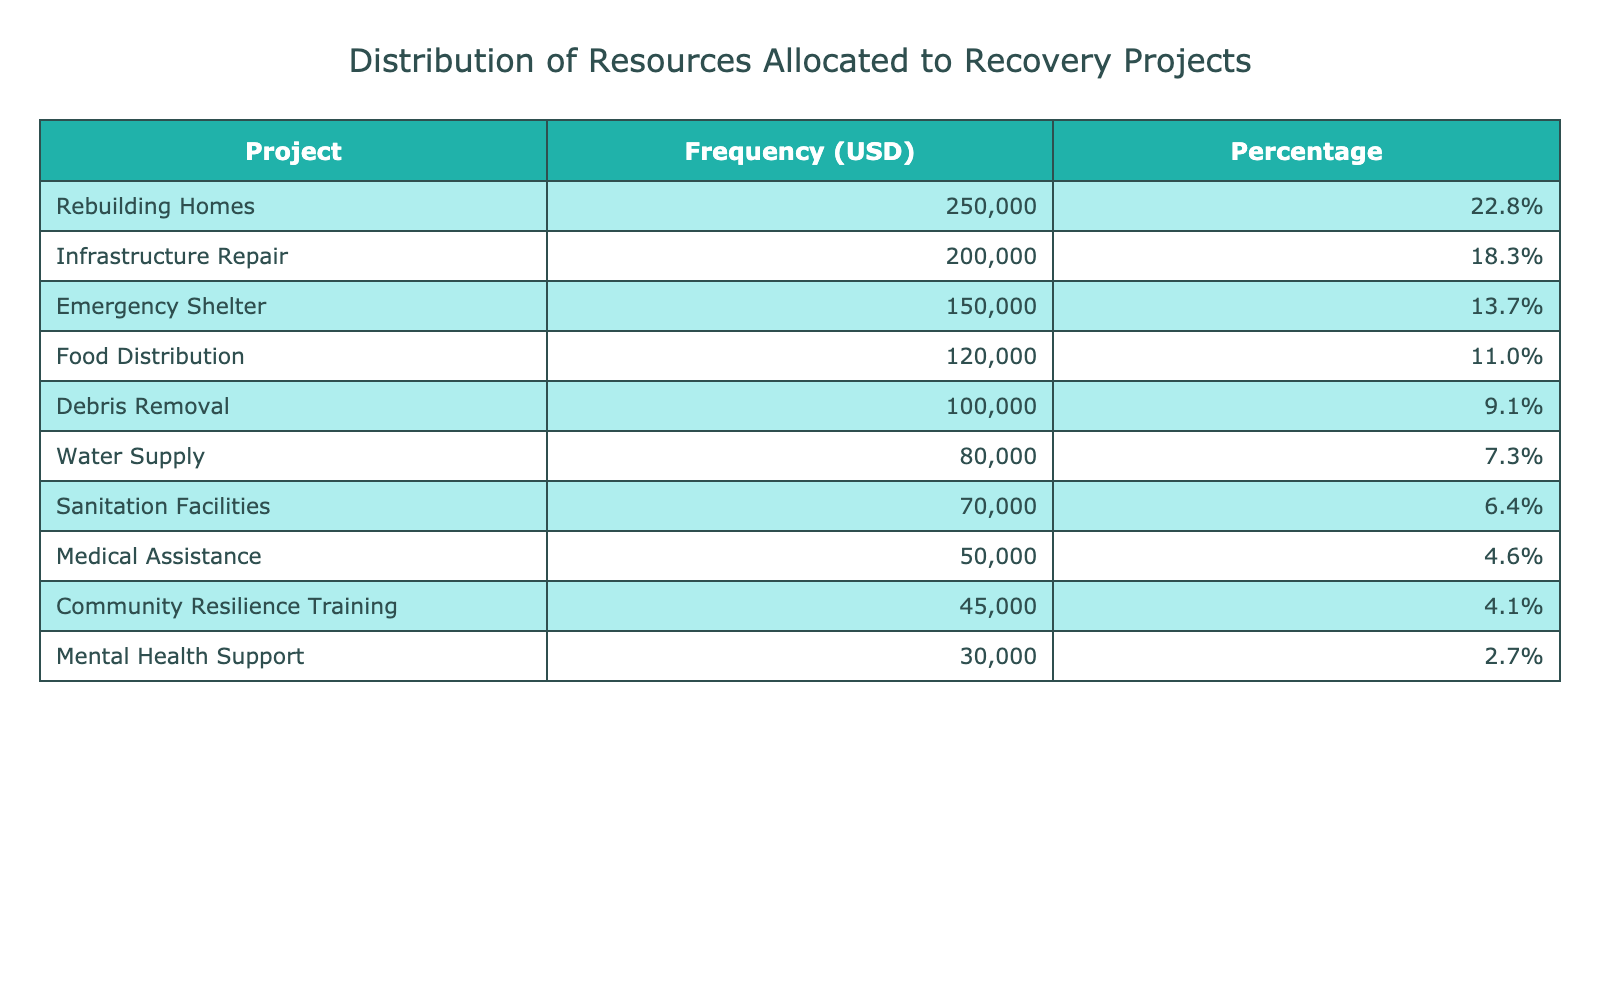What is the total resource allocation for all projects? The total resource allocation can be found by summing up all the values in the "Resource Allocation USD" column: 150000 + 80000 + 120000 + 50000 + 200000 + 30000 + 45000 + 100000 + 70000 + 250000 = 1095000.
Answer: 1095000 Which project received the highest allocation? To find the project with the highest allocation, we look for the maximum value in the "Frequency (USD)" column. The highest value is 250000, corresponding to the "Rebuilding Homes" project.
Answer: Rebuilding Homes What percentage of the total resources was allocated to Medical Assistance? First, we find the resource allocation for Medical Assistance, which is 50000. Then we calculate its percentage of the total allocation: (50000 / 1095000) * 100 ≈ 4.6%.
Answer: 4.6% How many projects received more than 100000 USD? We count the projects where the allocated resources are greater than 100000. Those projects are "Emergency Shelter" (150000), "Food Distribution" (120000), "Infrastructure Repair" (200000), and "Rebuilding Homes" (250000). This gives us a total of 4 projects.
Answer: 4 Is the resource allocation for Community Resilience Training less than 5% of the total allocation? The resource allocation for Community Resilience Training is 45000. Its percentage of the total allocation is (45000 / 1095000) * 100 ≈ 4.1%. Since 4.1% is less than 5%, the answer is yes.
Answer: Yes What is the difference between the highest and the lowest resource allocation? The highest allocation is 250000 (Rebuilding Homes) and the lowest is 30000 (Mental Health Support). The difference is 250000 - 30000 = 220000.
Answer: 220000 What two projects have the closest resource allocations? By examining the "Frequency (USD)" values, "Water Supply" (80000) and "Sanitation Facilities" (70000) have the closest allocations of 80000 and 70000. The difference between them is 10000.
Answer: Water Supply and Sanitation Facilities What is the average resource allocation across all projects? To find the average, we sum all resource allocations (1095000) and divide by the number of projects (10). Thus, the average is 1095000 / 10 = 109500.
Answer: 109500 